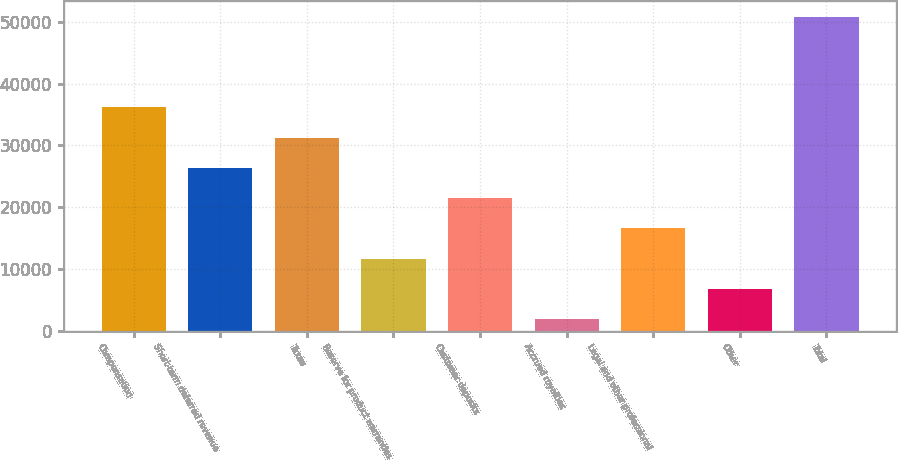<chart> <loc_0><loc_0><loc_500><loc_500><bar_chart><fcel>Compensation<fcel>Short-term deferred revenue<fcel>Taxes<fcel>Reserve for product warranties<fcel>Customer deposits<fcel>Accrued royalties<fcel>Legal and other professional<fcel>Other<fcel>Total<nl><fcel>36156.5<fcel>26359.5<fcel>31258<fcel>11664<fcel>21461<fcel>1867<fcel>16562.5<fcel>6765.5<fcel>50852<nl></chart> 